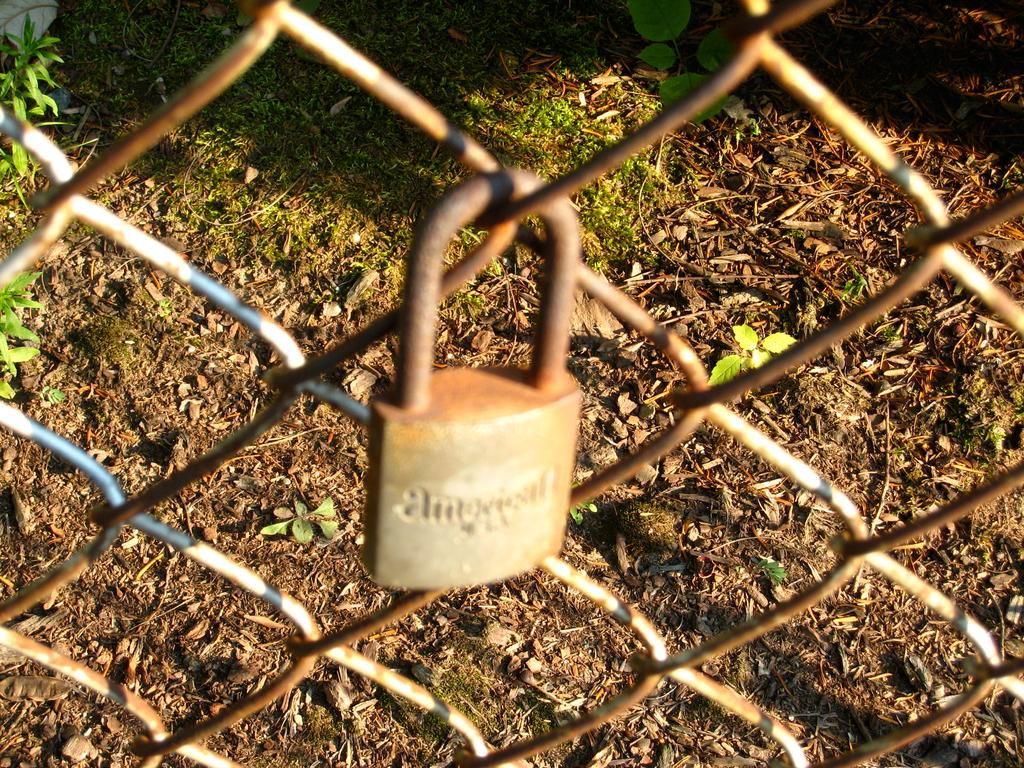What is securing the grill in the image? There is a lock on the grill in the image. What type of vegetation can be seen in the background of the image? There is grass in the background of the image. What additional natural elements are present in the image? There are leaves in the image. How many cats are sitting on the lock in the image? There are no cats present in the image; it only features a lock on a grill. What time of day is depicted in the image? The time of day cannot be determined from the image, as there are no specific indicators of morning or any other time. 